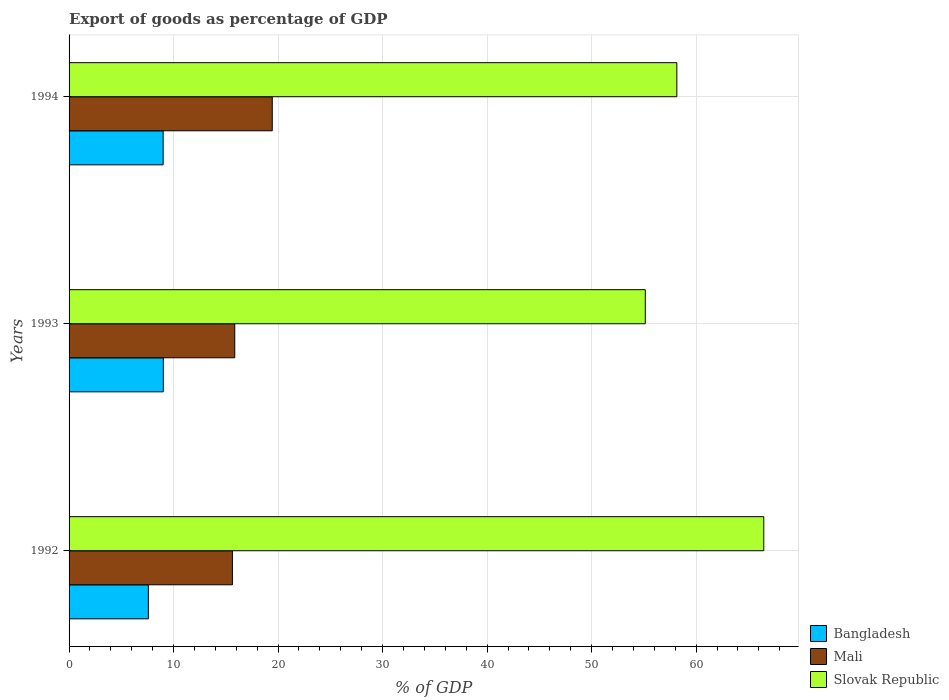How many groups of bars are there?
Offer a very short reply. 3. How many bars are there on the 3rd tick from the top?
Your answer should be very brief. 3. What is the label of the 3rd group of bars from the top?
Your answer should be very brief. 1992. In how many cases, is the number of bars for a given year not equal to the number of legend labels?
Your response must be concise. 0. What is the export of goods as percentage of GDP in Slovak Republic in 1993?
Keep it short and to the point. 55.14. Across all years, what is the maximum export of goods as percentage of GDP in Bangladesh?
Keep it short and to the point. 9.02. Across all years, what is the minimum export of goods as percentage of GDP in Slovak Republic?
Your answer should be compact. 55.14. In which year was the export of goods as percentage of GDP in Bangladesh maximum?
Provide a succinct answer. 1993. What is the total export of goods as percentage of GDP in Bangladesh in the graph?
Your answer should be very brief. 25.61. What is the difference between the export of goods as percentage of GDP in Mali in 1993 and that in 1994?
Your answer should be compact. -3.59. What is the difference between the export of goods as percentage of GDP in Slovak Republic in 1994 and the export of goods as percentage of GDP in Bangladesh in 1993?
Your answer should be very brief. 49.14. What is the average export of goods as percentage of GDP in Slovak Republic per year?
Offer a terse response. 59.92. In the year 1993, what is the difference between the export of goods as percentage of GDP in Slovak Republic and export of goods as percentage of GDP in Mali?
Your response must be concise. 39.28. What is the ratio of the export of goods as percentage of GDP in Mali in 1992 to that in 1993?
Your answer should be very brief. 0.99. Is the export of goods as percentage of GDP in Slovak Republic in 1993 less than that in 1994?
Your answer should be compact. Yes. What is the difference between the highest and the second highest export of goods as percentage of GDP in Slovak Republic?
Offer a terse response. 8.32. What is the difference between the highest and the lowest export of goods as percentage of GDP in Slovak Republic?
Your response must be concise. 11.34. In how many years, is the export of goods as percentage of GDP in Mali greater than the average export of goods as percentage of GDP in Mali taken over all years?
Give a very brief answer. 1. Is the sum of the export of goods as percentage of GDP in Slovak Republic in 1993 and 1994 greater than the maximum export of goods as percentage of GDP in Mali across all years?
Offer a very short reply. Yes. What does the 1st bar from the top in 1994 represents?
Provide a succinct answer. Slovak Republic. What does the 3rd bar from the bottom in 1992 represents?
Provide a short and direct response. Slovak Republic. Is it the case that in every year, the sum of the export of goods as percentage of GDP in Slovak Republic and export of goods as percentage of GDP in Mali is greater than the export of goods as percentage of GDP in Bangladesh?
Your answer should be very brief. Yes. How many bars are there?
Offer a very short reply. 9. Are all the bars in the graph horizontal?
Provide a succinct answer. Yes. How many years are there in the graph?
Ensure brevity in your answer.  3. What is the difference between two consecutive major ticks on the X-axis?
Make the answer very short. 10. Are the values on the major ticks of X-axis written in scientific E-notation?
Provide a short and direct response. No. Does the graph contain any zero values?
Keep it short and to the point. No. What is the title of the graph?
Your answer should be very brief. Export of goods as percentage of GDP. Does "Dominican Republic" appear as one of the legend labels in the graph?
Provide a succinct answer. No. What is the label or title of the X-axis?
Your response must be concise. % of GDP. What is the label or title of the Y-axis?
Ensure brevity in your answer.  Years. What is the % of GDP of Bangladesh in 1992?
Ensure brevity in your answer.  7.59. What is the % of GDP of Mali in 1992?
Your answer should be compact. 15.63. What is the % of GDP in Slovak Republic in 1992?
Offer a very short reply. 66.47. What is the % of GDP in Bangladesh in 1993?
Ensure brevity in your answer.  9.02. What is the % of GDP of Mali in 1993?
Give a very brief answer. 15.85. What is the % of GDP in Slovak Republic in 1993?
Your answer should be compact. 55.14. What is the % of GDP in Bangladesh in 1994?
Keep it short and to the point. 9. What is the % of GDP of Mali in 1994?
Provide a short and direct response. 19.44. What is the % of GDP of Slovak Republic in 1994?
Provide a succinct answer. 58.15. Across all years, what is the maximum % of GDP of Bangladesh?
Keep it short and to the point. 9.02. Across all years, what is the maximum % of GDP of Mali?
Your answer should be compact. 19.44. Across all years, what is the maximum % of GDP in Slovak Republic?
Provide a short and direct response. 66.47. Across all years, what is the minimum % of GDP of Bangladesh?
Give a very brief answer. 7.59. Across all years, what is the minimum % of GDP of Mali?
Your response must be concise. 15.63. Across all years, what is the minimum % of GDP of Slovak Republic?
Provide a short and direct response. 55.14. What is the total % of GDP of Bangladesh in the graph?
Keep it short and to the point. 25.61. What is the total % of GDP in Mali in the graph?
Your response must be concise. 50.93. What is the total % of GDP in Slovak Republic in the graph?
Your answer should be very brief. 179.77. What is the difference between the % of GDP of Bangladesh in 1992 and that in 1993?
Provide a succinct answer. -1.43. What is the difference between the % of GDP of Mali in 1992 and that in 1993?
Provide a succinct answer. -0.22. What is the difference between the % of GDP of Slovak Republic in 1992 and that in 1993?
Offer a terse response. 11.34. What is the difference between the % of GDP of Bangladesh in 1992 and that in 1994?
Your answer should be very brief. -1.41. What is the difference between the % of GDP of Mali in 1992 and that in 1994?
Make the answer very short. -3.81. What is the difference between the % of GDP in Slovak Republic in 1992 and that in 1994?
Provide a succinct answer. 8.32. What is the difference between the % of GDP in Bangladesh in 1993 and that in 1994?
Your answer should be compact. 0.02. What is the difference between the % of GDP in Mali in 1993 and that in 1994?
Give a very brief answer. -3.59. What is the difference between the % of GDP of Slovak Republic in 1993 and that in 1994?
Your answer should be very brief. -3.02. What is the difference between the % of GDP of Bangladesh in 1992 and the % of GDP of Mali in 1993?
Keep it short and to the point. -8.27. What is the difference between the % of GDP in Bangladesh in 1992 and the % of GDP in Slovak Republic in 1993?
Ensure brevity in your answer.  -47.55. What is the difference between the % of GDP of Mali in 1992 and the % of GDP of Slovak Republic in 1993?
Provide a short and direct response. -39.51. What is the difference between the % of GDP in Bangladesh in 1992 and the % of GDP in Mali in 1994?
Offer a very short reply. -11.86. What is the difference between the % of GDP in Bangladesh in 1992 and the % of GDP in Slovak Republic in 1994?
Provide a succinct answer. -50.57. What is the difference between the % of GDP in Mali in 1992 and the % of GDP in Slovak Republic in 1994?
Provide a succinct answer. -42.53. What is the difference between the % of GDP of Bangladesh in 1993 and the % of GDP of Mali in 1994?
Ensure brevity in your answer.  -10.43. What is the difference between the % of GDP of Bangladesh in 1993 and the % of GDP of Slovak Republic in 1994?
Your answer should be compact. -49.14. What is the difference between the % of GDP in Mali in 1993 and the % of GDP in Slovak Republic in 1994?
Keep it short and to the point. -42.3. What is the average % of GDP in Bangladesh per year?
Offer a very short reply. 8.54. What is the average % of GDP in Mali per year?
Your answer should be very brief. 16.98. What is the average % of GDP in Slovak Republic per year?
Offer a very short reply. 59.92. In the year 1992, what is the difference between the % of GDP in Bangladesh and % of GDP in Mali?
Your answer should be compact. -8.04. In the year 1992, what is the difference between the % of GDP of Bangladesh and % of GDP of Slovak Republic?
Ensure brevity in your answer.  -58.89. In the year 1992, what is the difference between the % of GDP of Mali and % of GDP of Slovak Republic?
Offer a very short reply. -50.85. In the year 1993, what is the difference between the % of GDP of Bangladesh and % of GDP of Mali?
Make the answer very short. -6.84. In the year 1993, what is the difference between the % of GDP in Bangladesh and % of GDP in Slovak Republic?
Offer a very short reply. -46.12. In the year 1993, what is the difference between the % of GDP of Mali and % of GDP of Slovak Republic?
Your response must be concise. -39.28. In the year 1994, what is the difference between the % of GDP of Bangladesh and % of GDP of Mali?
Offer a terse response. -10.44. In the year 1994, what is the difference between the % of GDP in Bangladesh and % of GDP in Slovak Republic?
Your response must be concise. -49.15. In the year 1994, what is the difference between the % of GDP in Mali and % of GDP in Slovak Republic?
Give a very brief answer. -38.71. What is the ratio of the % of GDP of Bangladesh in 1992 to that in 1993?
Make the answer very short. 0.84. What is the ratio of the % of GDP of Mali in 1992 to that in 1993?
Offer a very short reply. 0.99. What is the ratio of the % of GDP of Slovak Republic in 1992 to that in 1993?
Your answer should be very brief. 1.21. What is the ratio of the % of GDP of Bangladesh in 1992 to that in 1994?
Offer a very short reply. 0.84. What is the ratio of the % of GDP of Mali in 1992 to that in 1994?
Your response must be concise. 0.8. What is the ratio of the % of GDP of Slovak Republic in 1992 to that in 1994?
Offer a very short reply. 1.14. What is the ratio of the % of GDP of Mali in 1993 to that in 1994?
Make the answer very short. 0.82. What is the ratio of the % of GDP of Slovak Republic in 1993 to that in 1994?
Keep it short and to the point. 0.95. What is the difference between the highest and the second highest % of GDP of Bangladesh?
Keep it short and to the point. 0.02. What is the difference between the highest and the second highest % of GDP of Mali?
Your answer should be compact. 3.59. What is the difference between the highest and the second highest % of GDP of Slovak Republic?
Make the answer very short. 8.32. What is the difference between the highest and the lowest % of GDP of Bangladesh?
Provide a succinct answer. 1.43. What is the difference between the highest and the lowest % of GDP of Mali?
Offer a terse response. 3.81. What is the difference between the highest and the lowest % of GDP of Slovak Republic?
Give a very brief answer. 11.34. 